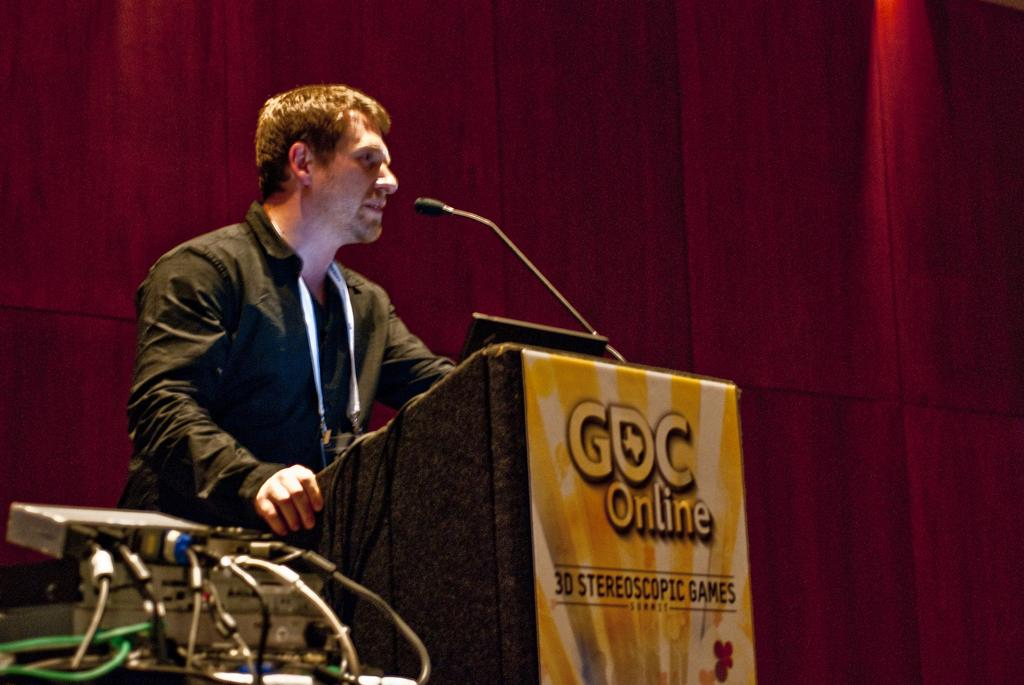<image>
Describe the image concisely. the letters GOC that is on a podium 